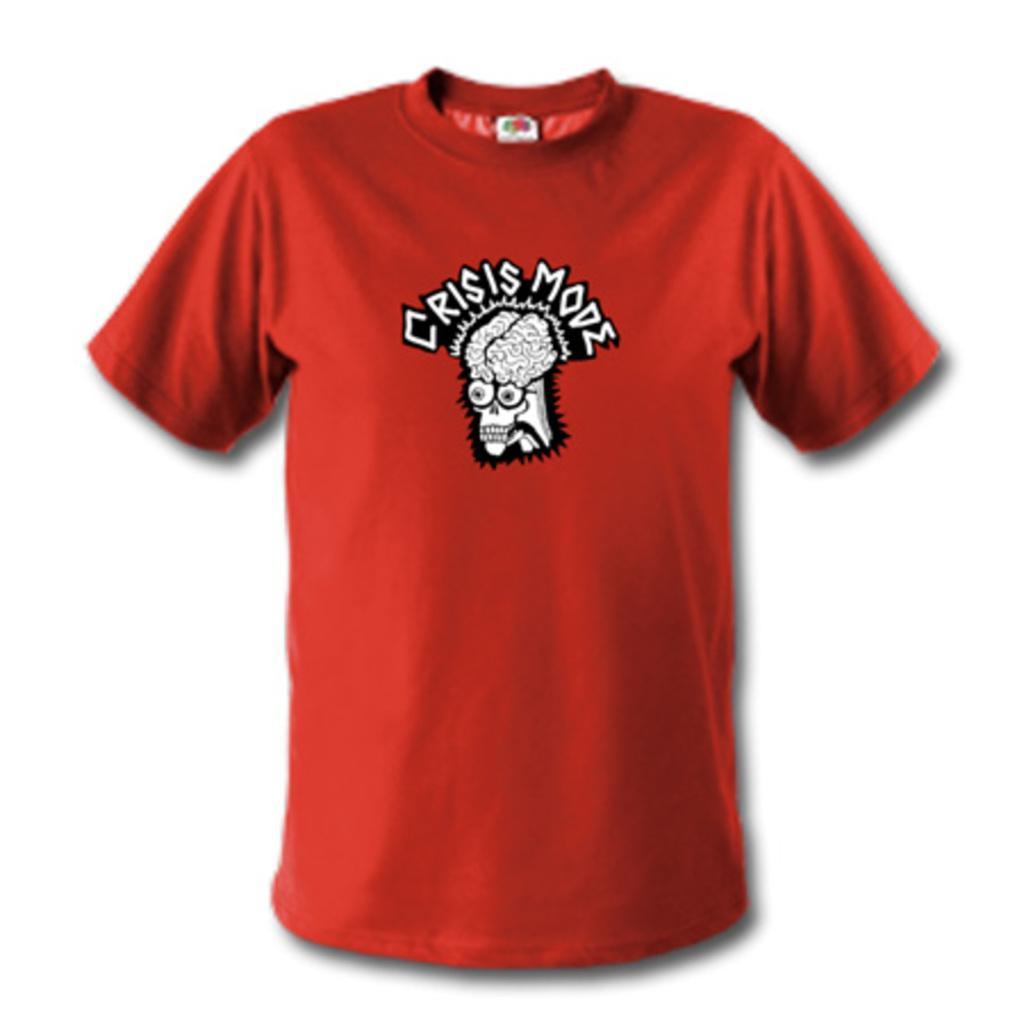Could you give a brief overview of what you see in this image? In this picture there is a red color t- shirt. Behind there is blur background. 